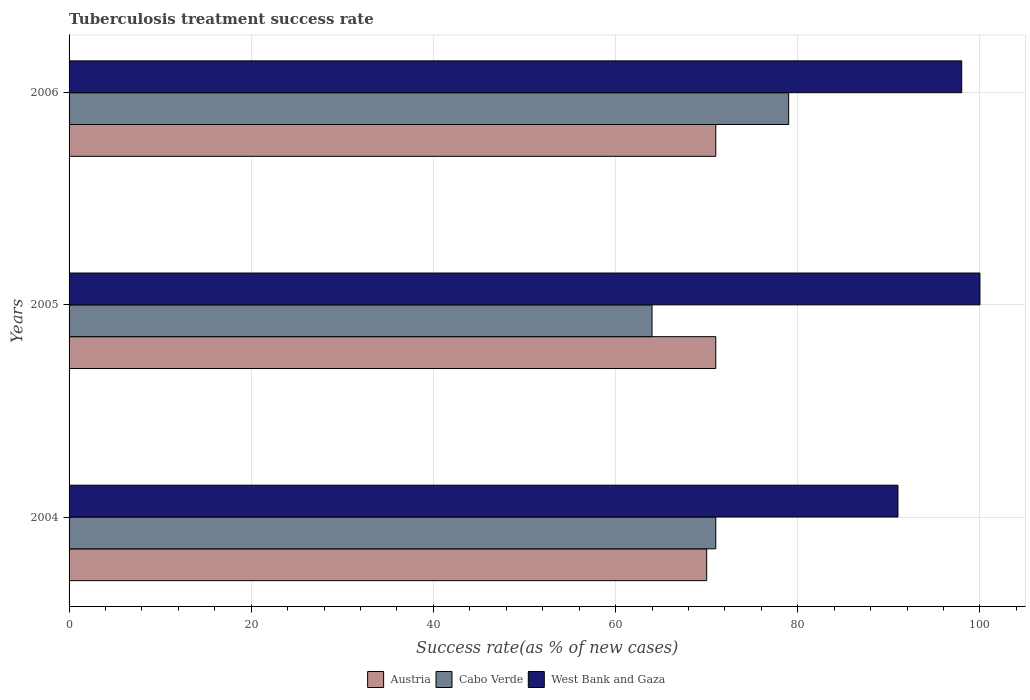How many different coloured bars are there?
Ensure brevity in your answer.  3. Are the number of bars per tick equal to the number of legend labels?
Provide a succinct answer. Yes. Are the number of bars on each tick of the Y-axis equal?
Provide a short and direct response. Yes. How many bars are there on the 1st tick from the bottom?
Provide a succinct answer. 3. What is the label of the 2nd group of bars from the top?
Your answer should be compact. 2005. In how many cases, is the number of bars for a given year not equal to the number of legend labels?
Provide a short and direct response. 0. Across all years, what is the minimum tuberculosis treatment success rate in West Bank and Gaza?
Keep it short and to the point. 91. In which year was the tuberculosis treatment success rate in West Bank and Gaza maximum?
Provide a short and direct response. 2005. In which year was the tuberculosis treatment success rate in Cabo Verde minimum?
Provide a succinct answer. 2005. What is the total tuberculosis treatment success rate in Cabo Verde in the graph?
Make the answer very short. 214. What is the difference between the tuberculosis treatment success rate in West Bank and Gaza in 2004 and that in 2006?
Provide a short and direct response. -7. What is the average tuberculosis treatment success rate in Cabo Verde per year?
Offer a very short reply. 71.33. In the year 2004, what is the difference between the tuberculosis treatment success rate in West Bank and Gaza and tuberculosis treatment success rate in Austria?
Keep it short and to the point. 21. What is the ratio of the tuberculosis treatment success rate in Cabo Verde in 2004 to that in 2005?
Your response must be concise. 1.11. What is the difference between the highest and the lowest tuberculosis treatment success rate in West Bank and Gaza?
Offer a terse response. 9. Is the sum of the tuberculosis treatment success rate in Austria in 2004 and 2005 greater than the maximum tuberculosis treatment success rate in West Bank and Gaza across all years?
Make the answer very short. Yes. What does the 2nd bar from the top in 2006 represents?
Provide a short and direct response. Cabo Verde. What does the 3rd bar from the bottom in 2005 represents?
Provide a succinct answer. West Bank and Gaza. Is it the case that in every year, the sum of the tuberculosis treatment success rate in West Bank and Gaza and tuberculosis treatment success rate in Austria is greater than the tuberculosis treatment success rate in Cabo Verde?
Make the answer very short. Yes. How many bars are there?
Your answer should be very brief. 9. Are all the bars in the graph horizontal?
Provide a short and direct response. Yes. Are the values on the major ticks of X-axis written in scientific E-notation?
Your answer should be compact. No. Does the graph contain grids?
Ensure brevity in your answer.  Yes. How are the legend labels stacked?
Your answer should be compact. Horizontal. What is the title of the graph?
Offer a terse response. Tuberculosis treatment success rate. Does "Indonesia" appear as one of the legend labels in the graph?
Offer a very short reply. No. What is the label or title of the X-axis?
Ensure brevity in your answer.  Success rate(as % of new cases). What is the Success rate(as % of new cases) of Austria in 2004?
Your answer should be compact. 70. What is the Success rate(as % of new cases) in Cabo Verde in 2004?
Make the answer very short. 71. What is the Success rate(as % of new cases) of West Bank and Gaza in 2004?
Make the answer very short. 91. What is the Success rate(as % of new cases) of Austria in 2005?
Offer a terse response. 71. What is the Success rate(as % of new cases) of Cabo Verde in 2006?
Ensure brevity in your answer.  79. Across all years, what is the maximum Success rate(as % of new cases) of Cabo Verde?
Provide a short and direct response. 79. Across all years, what is the maximum Success rate(as % of new cases) of West Bank and Gaza?
Provide a short and direct response. 100. Across all years, what is the minimum Success rate(as % of new cases) of West Bank and Gaza?
Offer a very short reply. 91. What is the total Success rate(as % of new cases) in Austria in the graph?
Provide a short and direct response. 212. What is the total Success rate(as % of new cases) in Cabo Verde in the graph?
Your answer should be compact. 214. What is the total Success rate(as % of new cases) of West Bank and Gaza in the graph?
Your answer should be compact. 289. What is the difference between the Success rate(as % of new cases) of Cabo Verde in 2004 and that in 2005?
Make the answer very short. 7. What is the difference between the Success rate(as % of new cases) of Austria in 2004 and that in 2006?
Provide a short and direct response. -1. What is the difference between the Success rate(as % of new cases) in Austria in 2005 and that in 2006?
Make the answer very short. 0. What is the difference between the Success rate(as % of new cases) of West Bank and Gaza in 2005 and that in 2006?
Keep it short and to the point. 2. What is the difference between the Success rate(as % of new cases) of Austria in 2004 and the Success rate(as % of new cases) of West Bank and Gaza in 2005?
Your answer should be compact. -30. What is the difference between the Success rate(as % of new cases) in Cabo Verde in 2004 and the Success rate(as % of new cases) in West Bank and Gaza in 2005?
Your answer should be very brief. -29. What is the difference between the Success rate(as % of new cases) of Cabo Verde in 2004 and the Success rate(as % of new cases) of West Bank and Gaza in 2006?
Offer a very short reply. -27. What is the difference between the Success rate(as % of new cases) of Austria in 2005 and the Success rate(as % of new cases) of West Bank and Gaza in 2006?
Offer a very short reply. -27. What is the difference between the Success rate(as % of new cases) of Cabo Verde in 2005 and the Success rate(as % of new cases) of West Bank and Gaza in 2006?
Give a very brief answer. -34. What is the average Success rate(as % of new cases) of Austria per year?
Give a very brief answer. 70.67. What is the average Success rate(as % of new cases) in Cabo Verde per year?
Give a very brief answer. 71.33. What is the average Success rate(as % of new cases) of West Bank and Gaza per year?
Offer a terse response. 96.33. In the year 2004, what is the difference between the Success rate(as % of new cases) of Austria and Success rate(as % of new cases) of Cabo Verde?
Your answer should be very brief. -1. In the year 2004, what is the difference between the Success rate(as % of new cases) of Cabo Verde and Success rate(as % of new cases) of West Bank and Gaza?
Ensure brevity in your answer.  -20. In the year 2005, what is the difference between the Success rate(as % of new cases) in Austria and Success rate(as % of new cases) in Cabo Verde?
Ensure brevity in your answer.  7. In the year 2005, what is the difference between the Success rate(as % of new cases) of Austria and Success rate(as % of new cases) of West Bank and Gaza?
Ensure brevity in your answer.  -29. In the year 2005, what is the difference between the Success rate(as % of new cases) of Cabo Verde and Success rate(as % of new cases) of West Bank and Gaza?
Make the answer very short. -36. In the year 2006, what is the difference between the Success rate(as % of new cases) of Austria and Success rate(as % of new cases) of Cabo Verde?
Give a very brief answer. -8. In the year 2006, what is the difference between the Success rate(as % of new cases) of Austria and Success rate(as % of new cases) of West Bank and Gaza?
Ensure brevity in your answer.  -27. What is the ratio of the Success rate(as % of new cases) in Austria in 2004 to that in 2005?
Offer a terse response. 0.99. What is the ratio of the Success rate(as % of new cases) of Cabo Verde in 2004 to that in 2005?
Give a very brief answer. 1.11. What is the ratio of the Success rate(as % of new cases) of West Bank and Gaza in 2004 to that in 2005?
Provide a succinct answer. 0.91. What is the ratio of the Success rate(as % of new cases) of Austria in 2004 to that in 2006?
Ensure brevity in your answer.  0.99. What is the ratio of the Success rate(as % of new cases) of Cabo Verde in 2004 to that in 2006?
Offer a very short reply. 0.9. What is the ratio of the Success rate(as % of new cases) in Austria in 2005 to that in 2006?
Provide a succinct answer. 1. What is the ratio of the Success rate(as % of new cases) in Cabo Verde in 2005 to that in 2006?
Provide a short and direct response. 0.81. What is the ratio of the Success rate(as % of new cases) in West Bank and Gaza in 2005 to that in 2006?
Keep it short and to the point. 1.02. What is the difference between the highest and the second highest Success rate(as % of new cases) in Austria?
Ensure brevity in your answer.  0. What is the difference between the highest and the lowest Success rate(as % of new cases) of Cabo Verde?
Your answer should be compact. 15. 